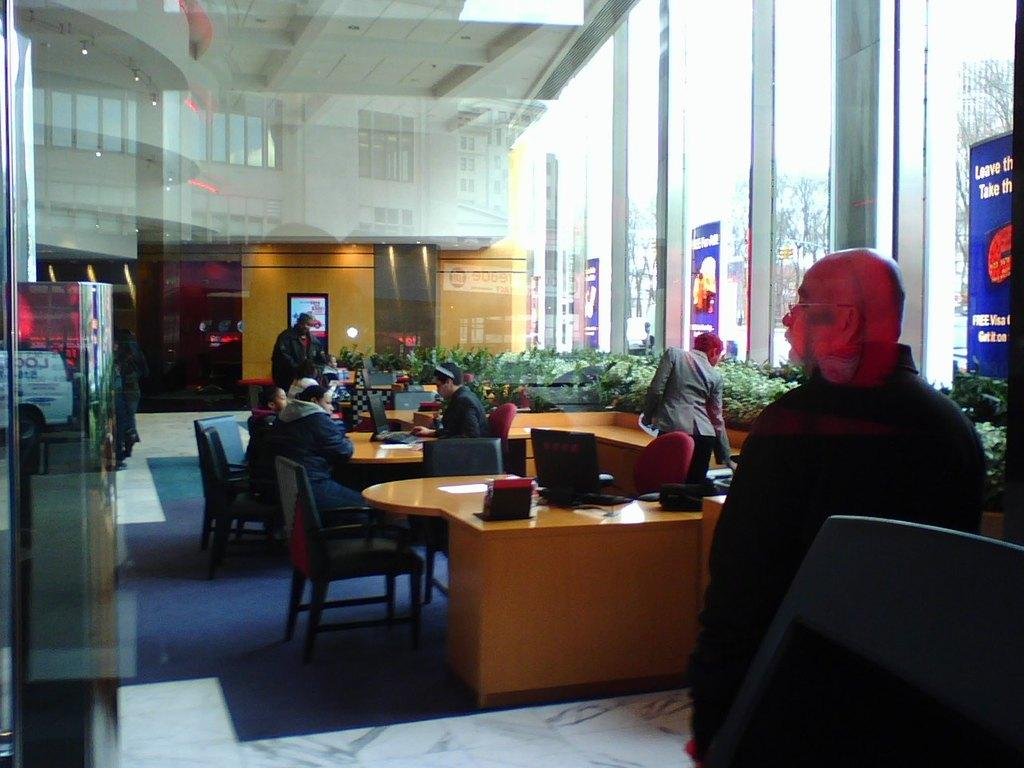What type of setting is depicted in the image? There is an office in the image. What are the people in the image doing? Some people are sitting and working with laptops, while others are standing. What type of vegetation can be seen in the image? There are plants in the image. What type of signage is present in the image? There are hoardings in the image. Can you tell me what type of club the father is holding in the image? There is no club or father present in the image. What type of rifle is visible in the image? There is no rifle present in the image. 